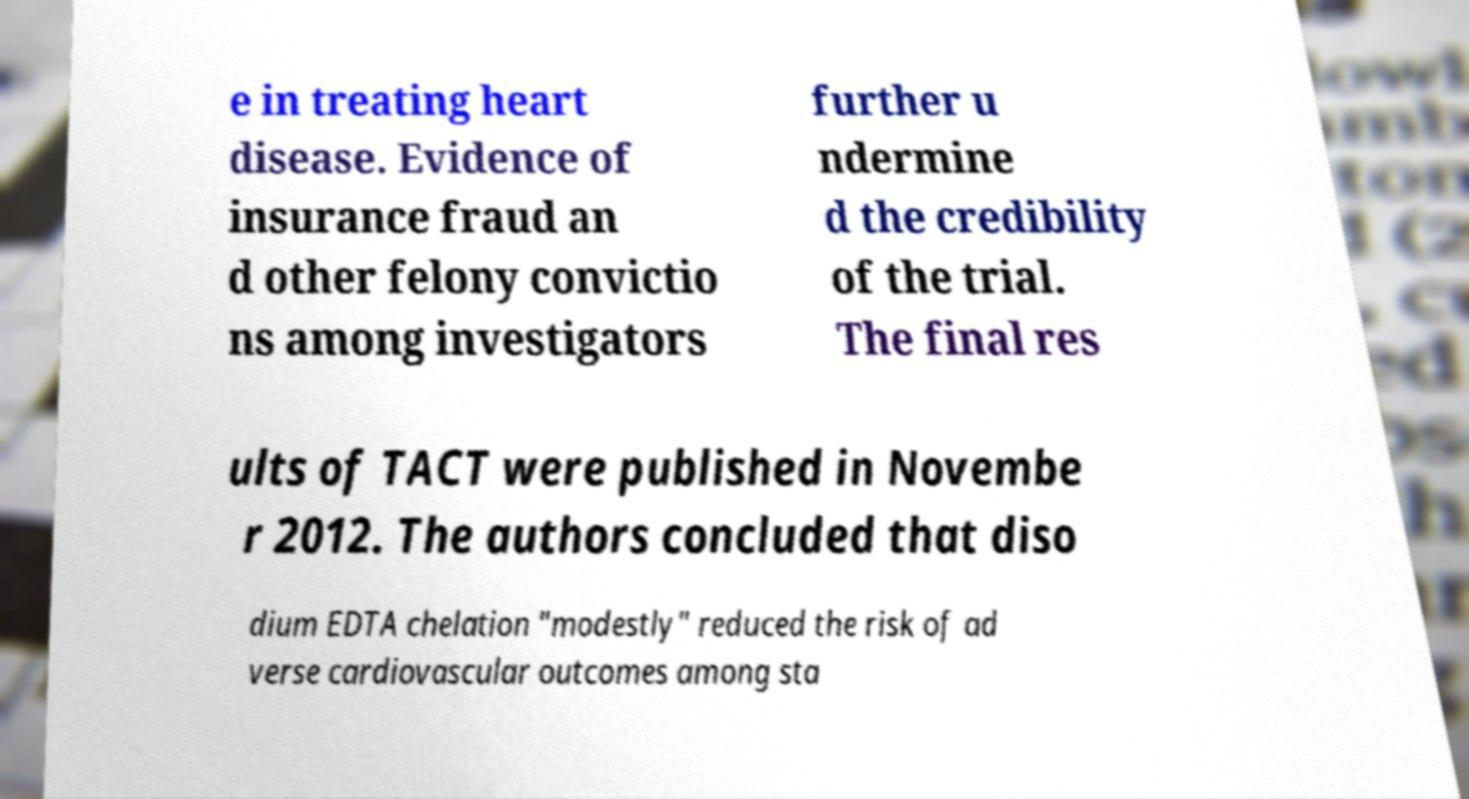I need the written content from this picture converted into text. Can you do that? e in treating heart disease. Evidence of insurance fraud an d other felony convictio ns among investigators further u ndermine d the credibility of the trial. The final res ults of TACT were published in Novembe r 2012. The authors concluded that diso dium EDTA chelation "modestly" reduced the risk of ad verse cardiovascular outcomes among sta 